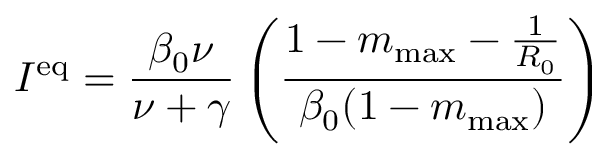Convert formula to latex. <formula><loc_0><loc_0><loc_500><loc_500>I ^ { e q } = \frac { \beta _ { 0 } \nu } { \nu + \gamma } \left ( \frac { 1 - m _ { \max } - \frac { 1 } { R _ { 0 } } } { \beta _ { 0 } ( 1 - m _ { \max } ) } \right )</formula> 